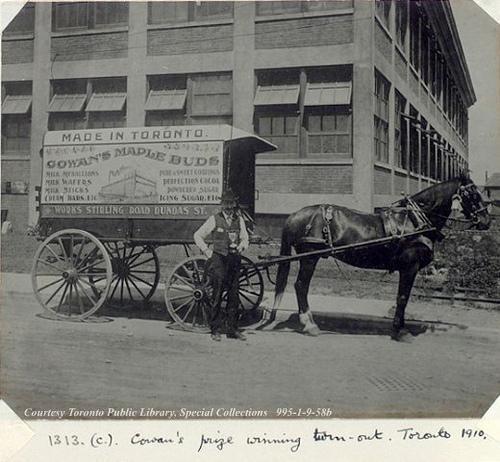How many horses are there?
Give a very brief answer. 1. How many wheels are on the carriage?
Give a very brief answer. 4. 